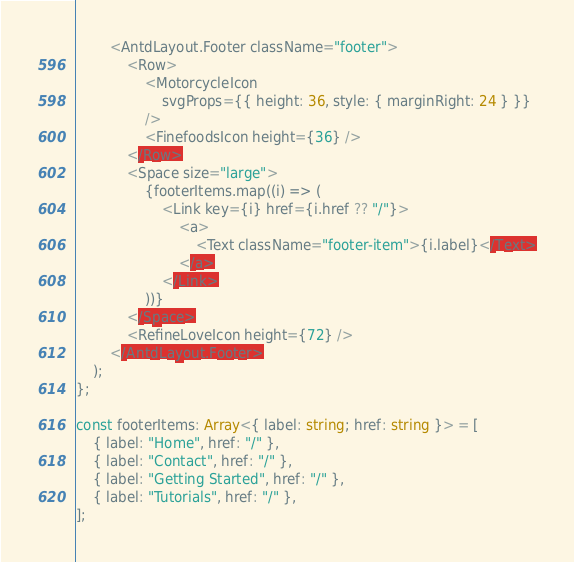Convert code to text. <code><loc_0><loc_0><loc_500><loc_500><_TypeScript_>        <AntdLayout.Footer className="footer">
            <Row>
                <MotorcycleIcon
                    svgProps={{ height: 36, style: { marginRight: 24 } }}
                />
                <FinefoodsIcon height={36} />
            </Row>
            <Space size="large">
                {footerItems.map((i) => (
                    <Link key={i} href={i.href ?? "/"}>
                        <a>
                            <Text className="footer-item">{i.label}</Text>
                        </a>
                    </Link>
                ))}
            </Space>
            <RefineLoveIcon height={72} />
        </AntdLayout.Footer>
    );
};

const footerItems: Array<{ label: string; href: string }> = [
    { label: "Home", href: "/" },
    { label: "Contact", href: "/" },
    { label: "Getting Started", href: "/" },
    { label: "Tutorials", href: "/" },
];
</code> 